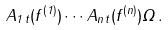Convert formula to latex. <formula><loc_0><loc_0><loc_500><loc_500>A _ { 1 \, t } ( f ^ { ( 1 ) } ) \cdots A _ { n \, t } ( f ^ { ( n ) } ) \Omega \, .</formula> 